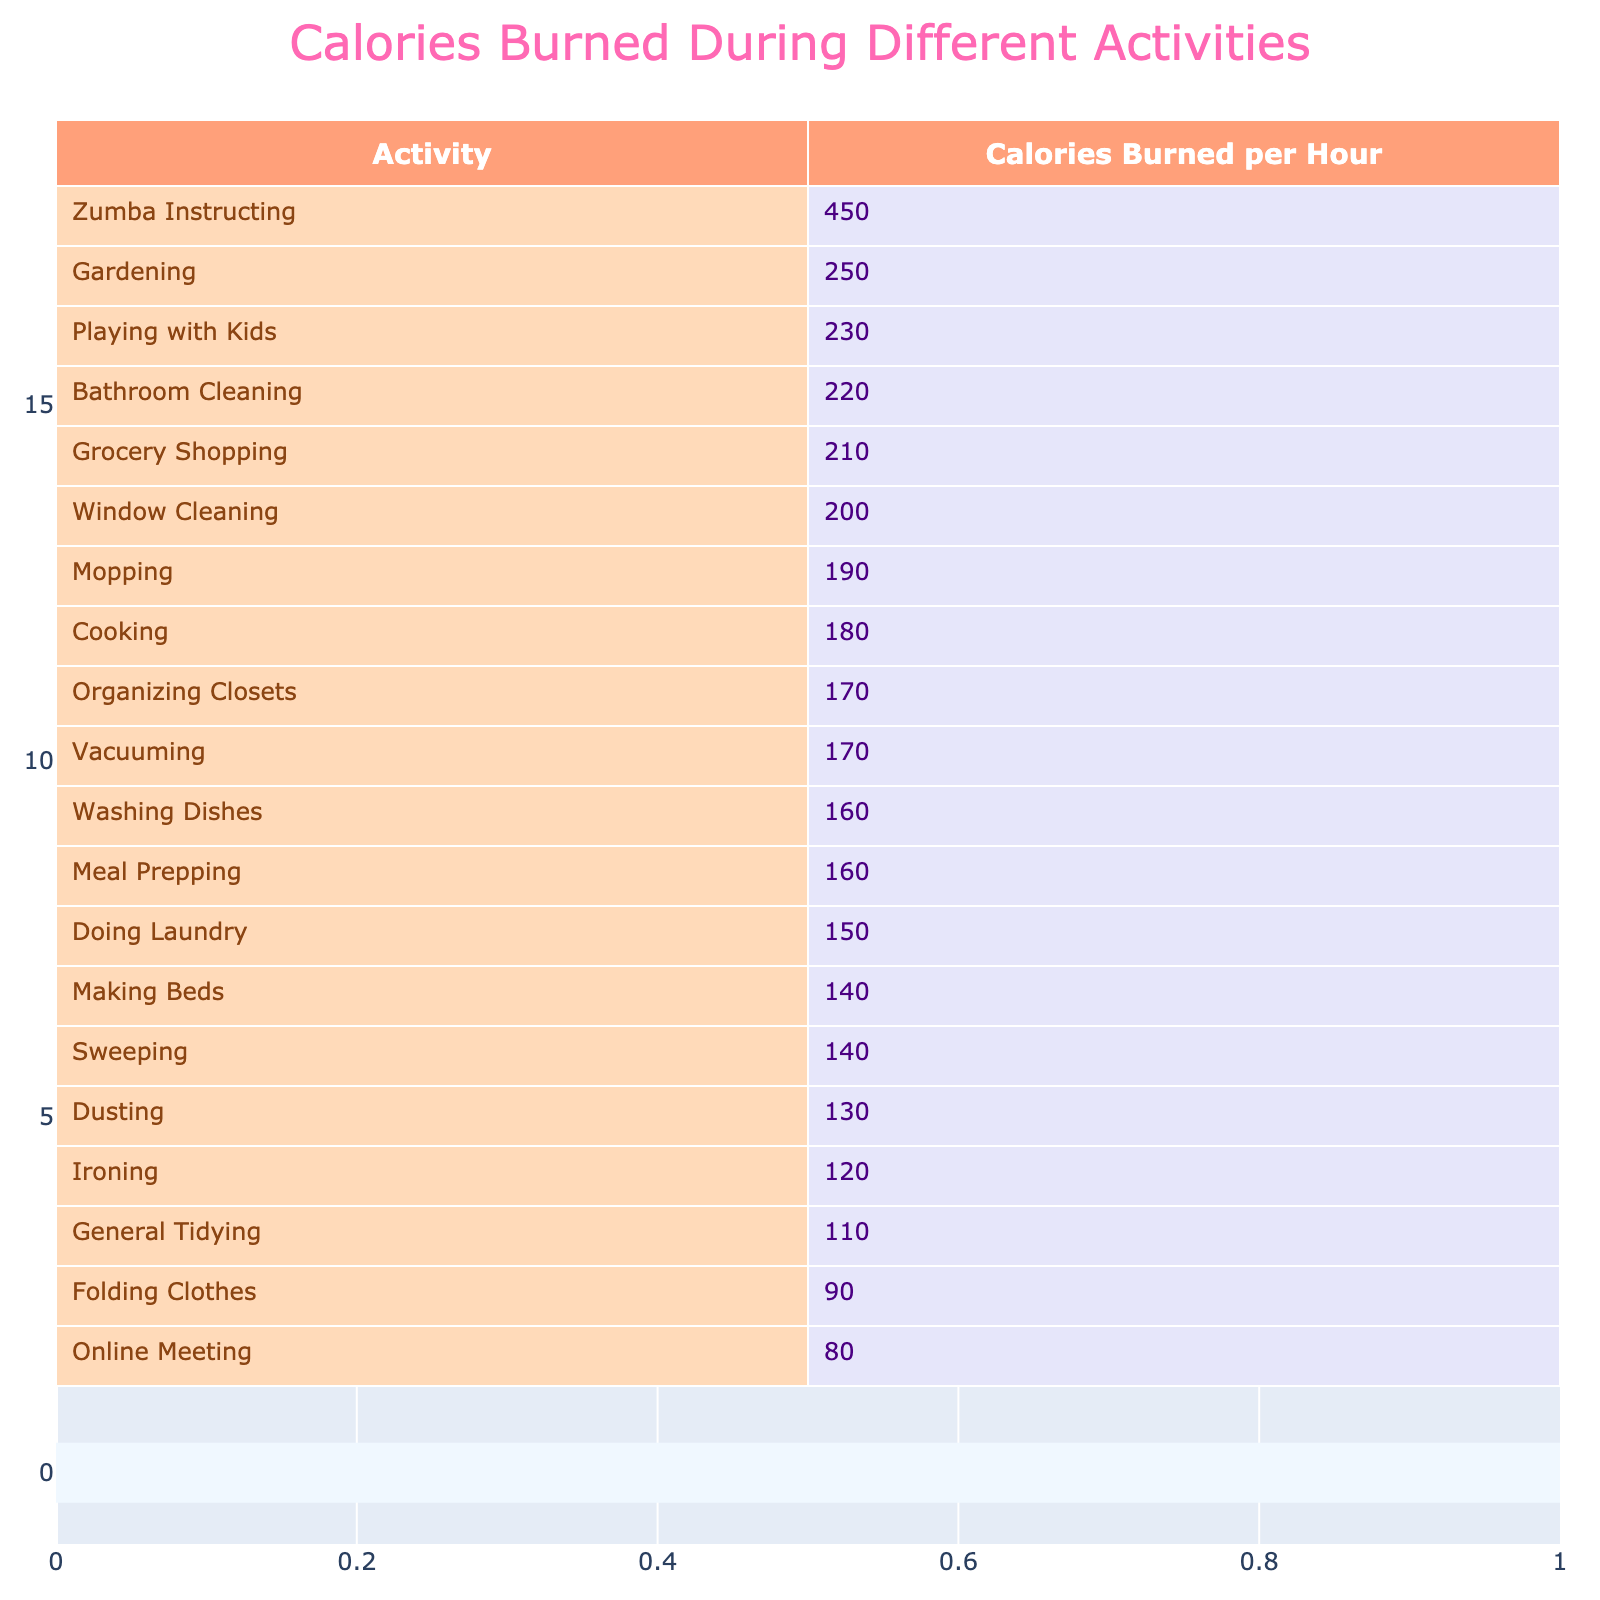What is the activity that burns the most calories per hour? By examining the table, the activity listed at the top with the highest "Calories Burned per Hour" is "Zumba Instructing" with 450 calories.
Answer: Zumba Instructing How many calories are burned while vacuuming? The table shows that vacuuming burns 170 calories per hour.
Answer: 170 calories Which activity burns more calories: ironing or dusting? Comparing the two activities, the table indicates ironing burns 120 calories while dusting burns 130 calories; thus, dusting burns more.
Answer: Dusting burns more What is the average number of calories burned for doing laundry, cooking, and meal prepping combined? The number of calories burned for each activity is: doing laundry (150), cooking (180), and meal prepping (160). Adding them gives 150 + 180 + 160 = 490. The average is 490 / 3 = approximately 163.33.
Answer: 163.33 calories Does grocery shopping burn more calories than general tidying? The table provides data: grocery shopping burns 210 calories while general tidying burns 110 calories; thus, grocery shopping burns more calories.
Answer: Yes What is the difference in calories burned between gardening and grocery shopping? Gardening burns 250 calories, and grocery shopping burns 210 calories. The difference is 250 - 210 = 40 calories.
Answer: 40 calories Identify the two activities that burn the least calories per hour. Sorting the table by calories burned shows that folding clothes (90 calories) and general tidying (110 calories) are the two activities that burn the least.
Answer: Folding clothes and general tidying What is the total number of calories burned when vacuuming, mopping, and washing dishes? From the table, vacuuming burns 170 calories, mopping burns 190 calories, and washing dishes burns 160 calories. The total is 170 + 190 + 160 = 520 calories.
Answer: 520 calories Which activity has the same number of calories burned as ironing? The table shows ironing burns 120 calories, and another activity with the same calorie burn is "Folding Clothes," which also burns 90 calories.
Answer: None (120 has no match) If you combine cooking and gardening, how many calories would you burn? Cooking burns 180 calories, and gardening burns 250 calories. The combined total is 180 + 250 = 430 calories.
Answer: 430 calories 